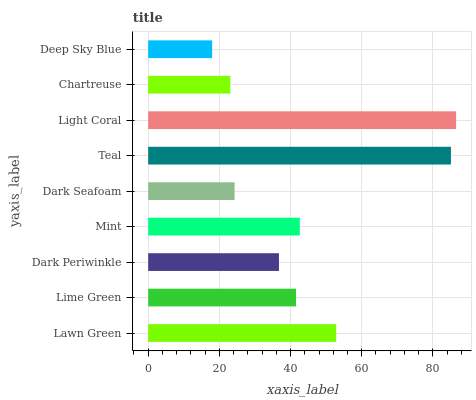Is Deep Sky Blue the minimum?
Answer yes or no. Yes. Is Light Coral the maximum?
Answer yes or no. Yes. Is Lime Green the minimum?
Answer yes or no. No. Is Lime Green the maximum?
Answer yes or no. No. Is Lawn Green greater than Lime Green?
Answer yes or no. Yes. Is Lime Green less than Lawn Green?
Answer yes or no. Yes. Is Lime Green greater than Lawn Green?
Answer yes or no. No. Is Lawn Green less than Lime Green?
Answer yes or no. No. Is Lime Green the high median?
Answer yes or no. Yes. Is Lime Green the low median?
Answer yes or no. Yes. Is Mint the high median?
Answer yes or no. No. Is Dark Seafoam the low median?
Answer yes or no. No. 